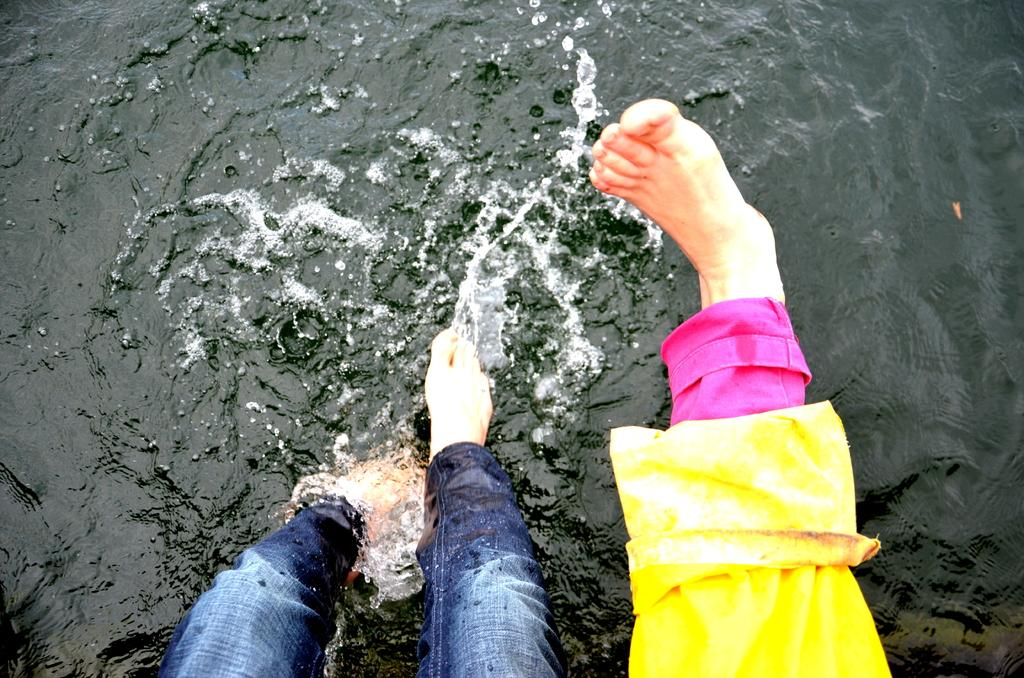What is the main subject in the center of the image? There are human legs with colorful costumes in the center of the image. What can be seen in the background of the image? There is water visible in the background of the image. Where is the mother sitting on her throne in the image? There is no mother or throne present in the image; it only features human legs with colorful costumes and water in the background. 